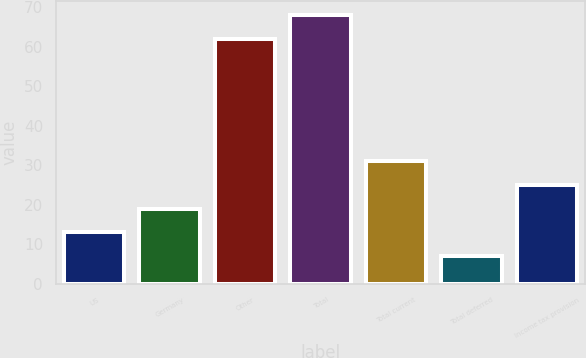Convert chart to OTSL. <chart><loc_0><loc_0><loc_500><loc_500><bar_chart><fcel>US<fcel>Germany<fcel>Other<fcel>Total<fcel>Total current<fcel>Total deferred<fcel>Income tax provision<nl><fcel>13<fcel>19<fcel>62<fcel>68<fcel>31<fcel>7<fcel>25<nl></chart> 